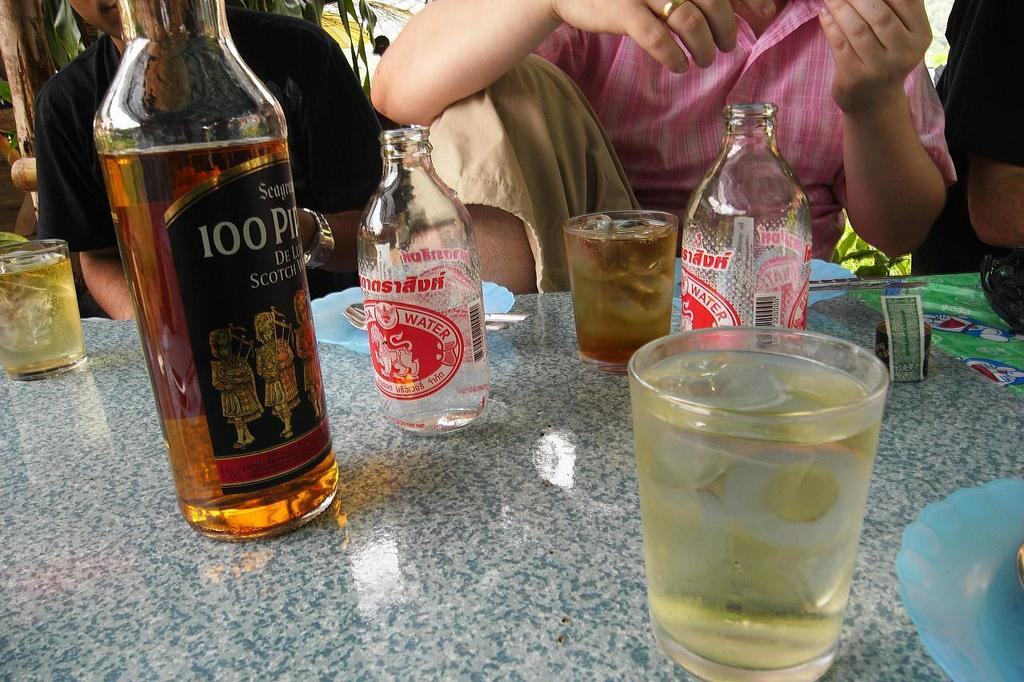What are the people in the image doing? The people in the image are sitting. What object can be seen near the people? There is a stone in the image. What is placed on the stone? A bottle and a glass are placed on the stone. Can you see a store in the image? There is no store present in the image. How many ladybugs are sitting on the stone? There are no ladybugs present in the image. 